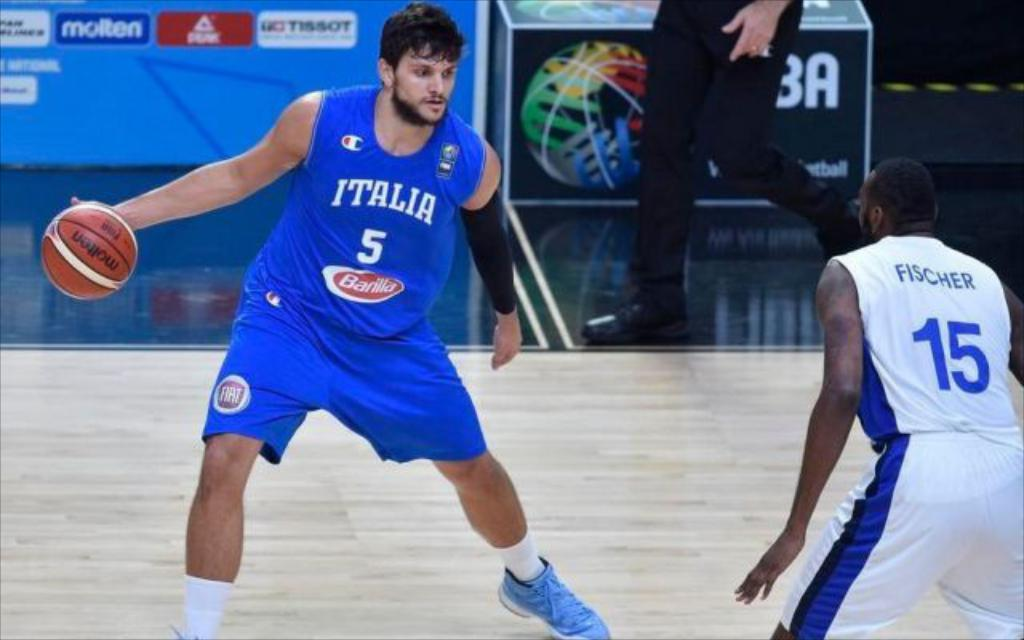Provide a one-sentence caption for the provided image. Two basketball players competing in a match and one player belongs to team Italy. 